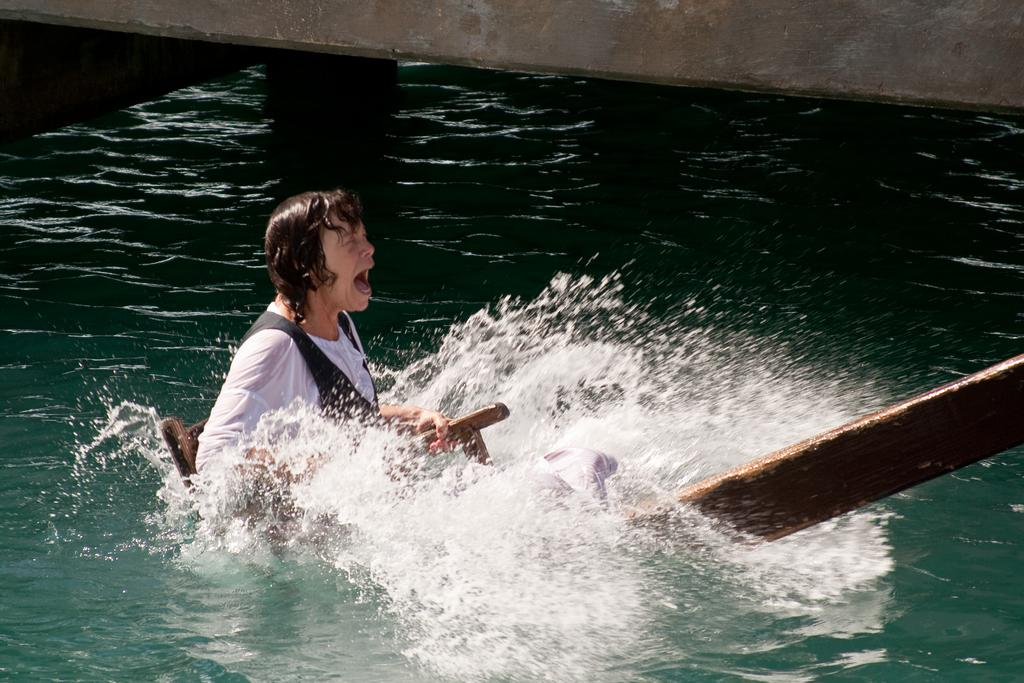What is the person in the image doing? The person is in the water and appears to be holding a wooden object. What is the person's emotional state in the image? The person appears to be shouting. What can be seen in the background of the image? There is a wall visible at the top of the image. How many ladybugs are crawling on the wooden object in the image? There are no ladybugs present in the image. What type of stitch is being used to sew the person's clothing in the image? The image does not show any clothing or stitching, so it cannot be determined. 